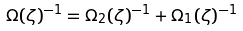Convert formula to latex. <formula><loc_0><loc_0><loc_500><loc_500>\Omega ( \zeta ) ^ { - 1 } = \Omega _ { 2 } ( \zeta ) ^ { - 1 } + \Omega _ { 1 } ( \zeta ) ^ { - 1 }</formula> 